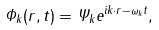<formula> <loc_0><loc_0><loc_500><loc_500>\Phi _ { k } ( r , t ) = \Psi _ { k } e ^ { i k \cdot r - \omega _ { k } t } ,</formula> 